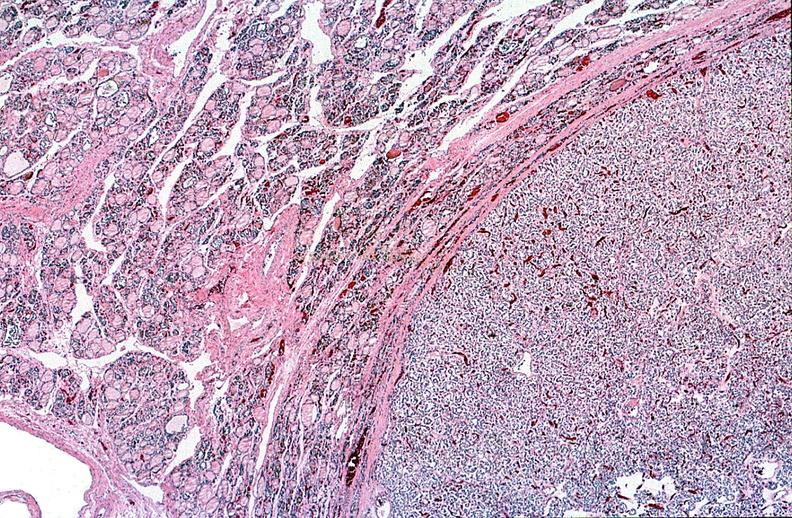does notochord show thyroid, follicular ademona?
Answer the question using a single word or phrase. No 